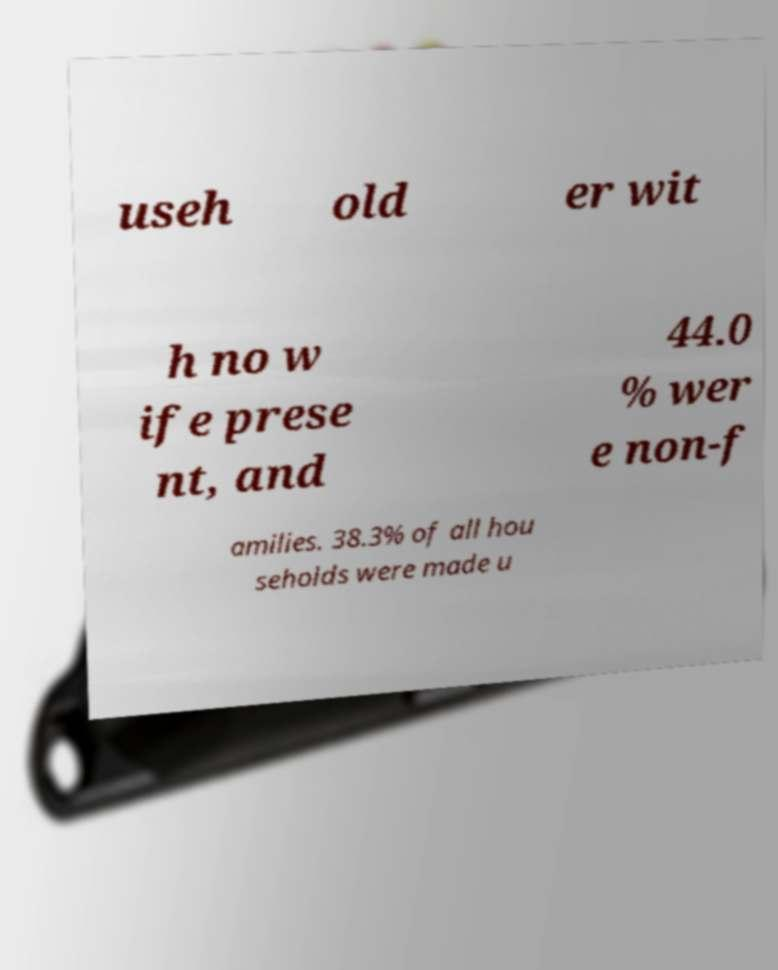I need the written content from this picture converted into text. Can you do that? useh old er wit h no w ife prese nt, and 44.0 % wer e non-f amilies. 38.3% of all hou seholds were made u 